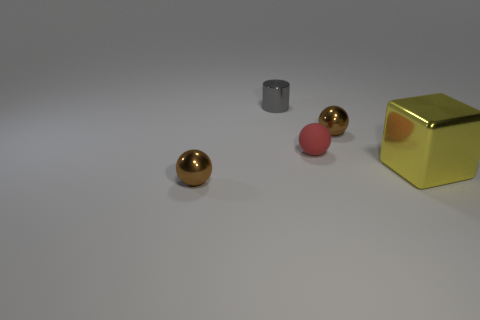What size is the gray cylinder that is the same material as the large cube?
Your answer should be very brief. Small. Do the brown object that is to the left of the cylinder and the brown object that is on the right side of the small metallic cylinder have the same size?
Keep it short and to the point. Yes. How many big things are either cyan rubber cylinders or blocks?
Your answer should be compact. 1. There is a small red thing that is right of the ball that is left of the gray shiny cylinder; what is it made of?
Provide a short and direct response. Rubber. Are there any cubes made of the same material as the gray cylinder?
Give a very brief answer. Yes. Is the material of the yellow block the same as the red ball that is behind the yellow object?
Provide a succinct answer. No. There is a metallic cylinder that is the same size as the red thing; what color is it?
Make the answer very short. Gray. What size is the brown metal ball behind the brown metal thing in front of the yellow block?
Your answer should be compact. Small. Are there fewer gray cylinders on the left side of the metal cylinder than blocks?
Your answer should be very brief. Yes. How many other objects are there of the same size as the rubber sphere?
Ensure brevity in your answer.  3. 